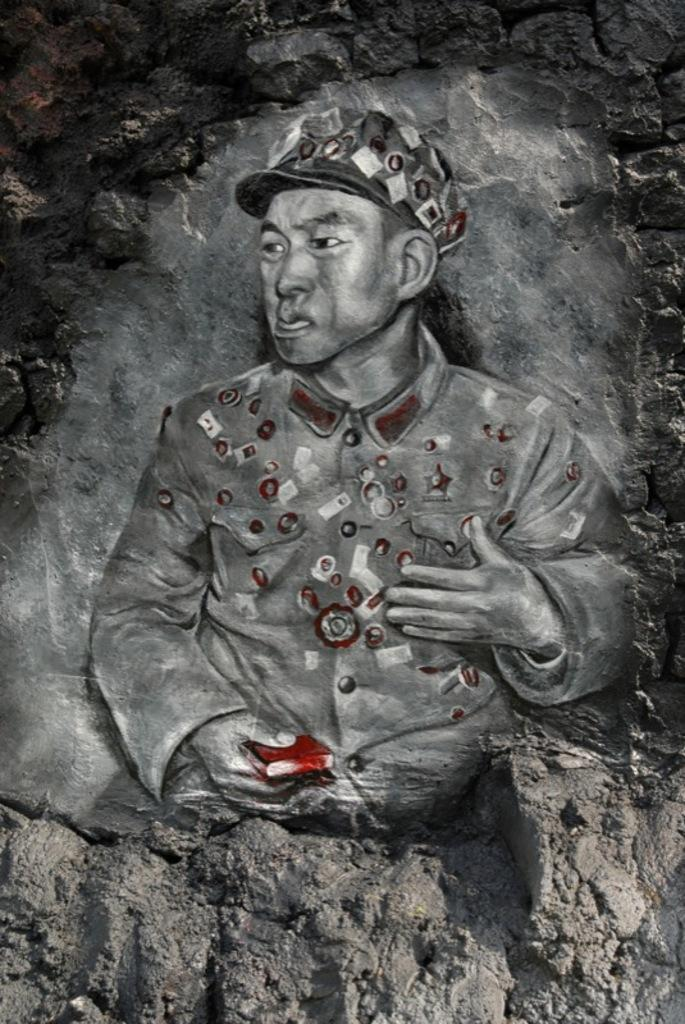What is depicted in the image? There is a painting of a person in the image. What material is the painting engraved on? The painting is engraved on a stone. What type of mitten is the person wearing in the painting? There is no mitten visible in the painting, as it is a person's portrait engraved on a stone. 